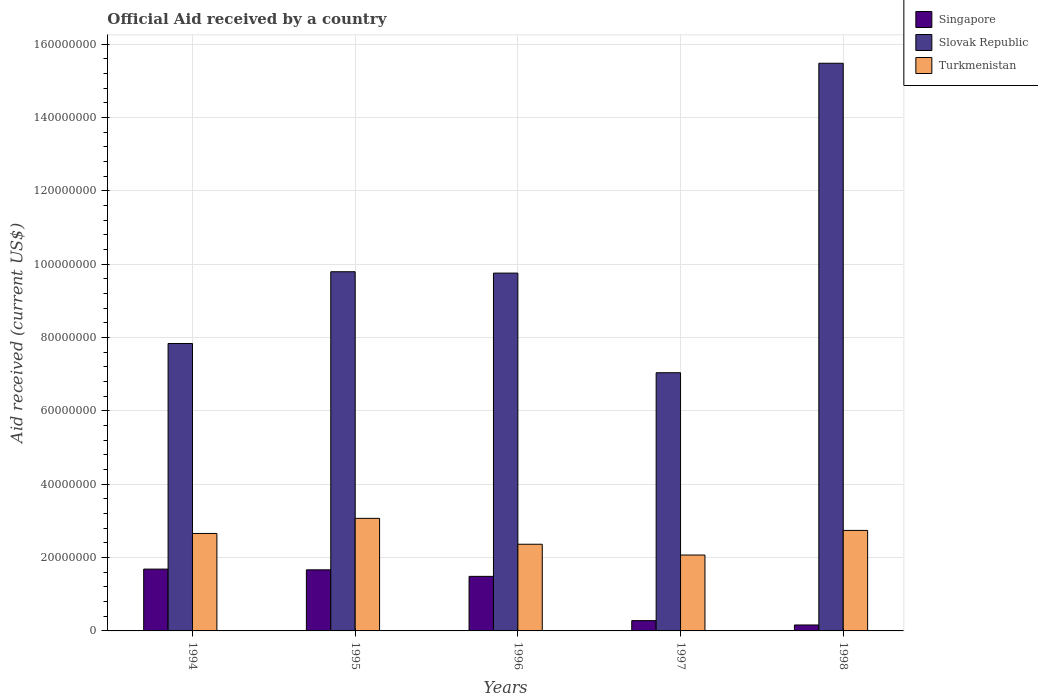Are the number of bars per tick equal to the number of legend labels?
Offer a very short reply. Yes. Are the number of bars on each tick of the X-axis equal?
Your answer should be very brief. Yes. In how many cases, is the number of bars for a given year not equal to the number of legend labels?
Provide a short and direct response. 0. What is the net official aid received in Singapore in 1996?
Your answer should be compact. 1.49e+07. Across all years, what is the maximum net official aid received in Slovak Republic?
Give a very brief answer. 1.55e+08. Across all years, what is the minimum net official aid received in Turkmenistan?
Your answer should be very brief. 2.07e+07. In which year was the net official aid received in Turkmenistan maximum?
Your answer should be compact. 1995. In which year was the net official aid received in Slovak Republic minimum?
Make the answer very short. 1997. What is the total net official aid received in Slovak Republic in the graph?
Give a very brief answer. 4.99e+08. What is the difference between the net official aid received in Turkmenistan in 1995 and that in 1998?
Provide a short and direct response. 3.29e+06. What is the difference between the net official aid received in Turkmenistan in 1997 and the net official aid received in Slovak Republic in 1994?
Your response must be concise. -5.77e+07. What is the average net official aid received in Turkmenistan per year?
Your answer should be very brief. 2.58e+07. In the year 1997, what is the difference between the net official aid received in Turkmenistan and net official aid received in Slovak Republic?
Ensure brevity in your answer.  -4.97e+07. What is the ratio of the net official aid received in Turkmenistan in 1994 to that in 1996?
Your answer should be very brief. 1.12. In how many years, is the net official aid received in Turkmenistan greater than the average net official aid received in Turkmenistan taken over all years?
Offer a very short reply. 3. What does the 2nd bar from the left in 1998 represents?
Offer a terse response. Slovak Republic. What does the 3rd bar from the right in 1997 represents?
Your answer should be very brief. Singapore. Are all the bars in the graph horizontal?
Offer a very short reply. No. How many years are there in the graph?
Provide a succinct answer. 5. What is the difference between two consecutive major ticks on the Y-axis?
Offer a terse response. 2.00e+07. Does the graph contain any zero values?
Provide a short and direct response. No. Does the graph contain grids?
Provide a short and direct response. Yes. What is the title of the graph?
Give a very brief answer. Official Aid received by a country. What is the label or title of the X-axis?
Offer a terse response. Years. What is the label or title of the Y-axis?
Offer a terse response. Aid received (current US$). What is the Aid received (current US$) in Singapore in 1994?
Provide a short and direct response. 1.69e+07. What is the Aid received (current US$) of Slovak Republic in 1994?
Make the answer very short. 7.84e+07. What is the Aid received (current US$) of Turkmenistan in 1994?
Provide a succinct answer. 2.66e+07. What is the Aid received (current US$) of Singapore in 1995?
Provide a succinct answer. 1.67e+07. What is the Aid received (current US$) in Slovak Republic in 1995?
Your answer should be compact. 9.80e+07. What is the Aid received (current US$) in Turkmenistan in 1995?
Your response must be concise. 3.07e+07. What is the Aid received (current US$) in Singapore in 1996?
Keep it short and to the point. 1.49e+07. What is the Aid received (current US$) of Slovak Republic in 1996?
Ensure brevity in your answer.  9.76e+07. What is the Aid received (current US$) in Turkmenistan in 1996?
Your answer should be compact. 2.36e+07. What is the Aid received (current US$) in Singapore in 1997?
Provide a succinct answer. 2.81e+06. What is the Aid received (current US$) of Slovak Republic in 1997?
Your response must be concise. 7.04e+07. What is the Aid received (current US$) in Turkmenistan in 1997?
Make the answer very short. 2.07e+07. What is the Aid received (current US$) in Singapore in 1998?
Provide a short and direct response. 1.62e+06. What is the Aid received (current US$) of Slovak Republic in 1998?
Ensure brevity in your answer.  1.55e+08. What is the Aid received (current US$) of Turkmenistan in 1998?
Your answer should be very brief. 2.74e+07. Across all years, what is the maximum Aid received (current US$) in Singapore?
Ensure brevity in your answer.  1.69e+07. Across all years, what is the maximum Aid received (current US$) of Slovak Republic?
Your answer should be very brief. 1.55e+08. Across all years, what is the maximum Aid received (current US$) of Turkmenistan?
Make the answer very short. 3.07e+07. Across all years, what is the minimum Aid received (current US$) of Singapore?
Keep it short and to the point. 1.62e+06. Across all years, what is the minimum Aid received (current US$) in Slovak Republic?
Provide a succinct answer. 7.04e+07. Across all years, what is the minimum Aid received (current US$) in Turkmenistan?
Provide a succinct answer. 2.07e+07. What is the total Aid received (current US$) of Singapore in the graph?
Provide a succinct answer. 5.28e+07. What is the total Aid received (current US$) in Slovak Republic in the graph?
Offer a very short reply. 4.99e+08. What is the total Aid received (current US$) of Turkmenistan in the graph?
Ensure brevity in your answer.  1.29e+08. What is the difference between the Aid received (current US$) of Slovak Republic in 1994 and that in 1995?
Your answer should be very brief. -1.96e+07. What is the difference between the Aid received (current US$) in Turkmenistan in 1994 and that in 1995?
Your answer should be very brief. -4.12e+06. What is the difference between the Aid received (current US$) in Singapore in 1994 and that in 1996?
Your answer should be compact. 1.98e+06. What is the difference between the Aid received (current US$) in Slovak Republic in 1994 and that in 1996?
Provide a short and direct response. -1.92e+07. What is the difference between the Aid received (current US$) in Turkmenistan in 1994 and that in 1996?
Give a very brief answer. 2.94e+06. What is the difference between the Aid received (current US$) of Singapore in 1994 and that in 1997?
Make the answer very short. 1.40e+07. What is the difference between the Aid received (current US$) of Slovak Republic in 1994 and that in 1997?
Your answer should be compact. 7.97e+06. What is the difference between the Aid received (current US$) of Turkmenistan in 1994 and that in 1997?
Offer a very short reply. 5.88e+06. What is the difference between the Aid received (current US$) of Singapore in 1994 and that in 1998?
Make the answer very short. 1.52e+07. What is the difference between the Aid received (current US$) of Slovak Republic in 1994 and that in 1998?
Your answer should be very brief. -7.64e+07. What is the difference between the Aid received (current US$) of Turkmenistan in 1994 and that in 1998?
Your answer should be compact. -8.30e+05. What is the difference between the Aid received (current US$) of Singapore in 1995 and that in 1996?
Keep it short and to the point. 1.78e+06. What is the difference between the Aid received (current US$) in Slovak Republic in 1995 and that in 1996?
Ensure brevity in your answer.  3.70e+05. What is the difference between the Aid received (current US$) of Turkmenistan in 1995 and that in 1996?
Ensure brevity in your answer.  7.06e+06. What is the difference between the Aid received (current US$) of Singapore in 1995 and that in 1997?
Offer a terse response. 1.38e+07. What is the difference between the Aid received (current US$) of Slovak Republic in 1995 and that in 1997?
Provide a short and direct response. 2.75e+07. What is the difference between the Aid received (current US$) of Turkmenistan in 1995 and that in 1997?
Ensure brevity in your answer.  1.00e+07. What is the difference between the Aid received (current US$) of Singapore in 1995 and that in 1998?
Give a very brief answer. 1.50e+07. What is the difference between the Aid received (current US$) of Slovak Republic in 1995 and that in 1998?
Your answer should be compact. -5.69e+07. What is the difference between the Aid received (current US$) in Turkmenistan in 1995 and that in 1998?
Make the answer very short. 3.29e+06. What is the difference between the Aid received (current US$) of Singapore in 1996 and that in 1997?
Ensure brevity in your answer.  1.21e+07. What is the difference between the Aid received (current US$) in Slovak Republic in 1996 and that in 1997?
Keep it short and to the point. 2.72e+07. What is the difference between the Aid received (current US$) of Turkmenistan in 1996 and that in 1997?
Keep it short and to the point. 2.94e+06. What is the difference between the Aid received (current US$) in Singapore in 1996 and that in 1998?
Your answer should be compact. 1.33e+07. What is the difference between the Aid received (current US$) in Slovak Republic in 1996 and that in 1998?
Ensure brevity in your answer.  -5.72e+07. What is the difference between the Aid received (current US$) of Turkmenistan in 1996 and that in 1998?
Ensure brevity in your answer.  -3.77e+06. What is the difference between the Aid received (current US$) in Singapore in 1997 and that in 1998?
Provide a succinct answer. 1.19e+06. What is the difference between the Aid received (current US$) of Slovak Republic in 1997 and that in 1998?
Ensure brevity in your answer.  -8.44e+07. What is the difference between the Aid received (current US$) of Turkmenistan in 1997 and that in 1998?
Give a very brief answer. -6.71e+06. What is the difference between the Aid received (current US$) in Singapore in 1994 and the Aid received (current US$) in Slovak Republic in 1995?
Offer a terse response. -8.11e+07. What is the difference between the Aid received (current US$) of Singapore in 1994 and the Aid received (current US$) of Turkmenistan in 1995?
Provide a short and direct response. -1.38e+07. What is the difference between the Aid received (current US$) of Slovak Republic in 1994 and the Aid received (current US$) of Turkmenistan in 1995?
Offer a terse response. 4.77e+07. What is the difference between the Aid received (current US$) of Singapore in 1994 and the Aid received (current US$) of Slovak Republic in 1996?
Give a very brief answer. -8.07e+07. What is the difference between the Aid received (current US$) in Singapore in 1994 and the Aid received (current US$) in Turkmenistan in 1996?
Your answer should be compact. -6.78e+06. What is the difference between the Aid received (current US$) in Slovak Republic in 1994 and the Aid received (current US$) in Turkmenistan in 1996?
Ensure brevity in your answer.  5.48e+07. What is the difference between the Aid received (current US$) of Singapore in 1994 and the Aid received (current US$) of Slovak Republic in 1997?
Provide a succinct answer. -5.36e+07. What is the difference between the Aid received (current US$) in Singapore in 1994 and the Aid received (current US$) in Turkmenistan in 1997?
Make the answer very short. -3.84e+06. What is the difference between the Aid received (current US$) in Slovak Republic in 1994 and the Aid received (current US$) in Turkmenistan in 1997?
Make the answer very short. 5.77e+07. What is the difference between the Aid received (current US$) of Singapore in 1994 and the Aid received (current US$) of Slovak Republic in 1998?
Your answer should be very brief. -1.38e+08. What is the difference between the Aid received (current US$) in Singapore in 1994 and the Aid received (current US$) in Turkmenistan in 1998?
Offer a terse response. -1.06e+07. What is the difference between the Aid received (current US$) in Slovak Republic in 1994 and the Aid received (current US$) in Turkmenistan in 1998?
Make the answer very short. 5.10e+07. What is the difference between the Aid received (current US$) in Singapore in 1995 and the Aid received (current US$) in Slovak Republic in 1996?
Ensure brevity in your answer.  -8.09e+07. What is the difference between the Aid received (current US$) of Singapore in 1995 and the Aid received (current US$) of Turkmenistan in 1996?
Offer a terse response. -6.98e+06. What is the difference between the Aid received (current US$) of Slovak Republic in 1995 and the Aid received (current US$) of Turkmenistan in 1996?
Ensure brevity in your answer.  7.43e+07. What is the difference between the Aid received (current US$) of Singapore in 1995 and the Aid received (current US$) of Slovak Republic in 1997?
Provide a short and direct response. -5.38e+07. What is the difference between the Aid received (current US$) of Singapore in 1995 and the Aid received (current US$) of Turkmenistan in 1997?
Provide a succinct answer. -4.04e+06. What is the difference between the Aid received (current US$) in Slovak Republic in 1995 and the Aid received (current US$) in Turkmenistan in 1997?
Ensure brevity in your answer.  7.73e+07. What is the difference between the Aid received (current US$) of Singapore in 1995 and the Aid received (current US$) of Slovak Republic in 1998?
Your response must be concise. -1.38e+08. What is the difference between the Aid received (current US$) of Singapore in 1995 and the Aid received (current US$) of Turkmenistan in 1998?
Give a very brief answer. -1.08e+07. What is the difference between the Aid received (current US$) in Slovak Republic in 1995 and the Aid received (current US$) in Turkmenistan in 1998?
Make the answer very short. 7.06e+07. What is the difference between the Aid received (current US$) of Singapore in 1996 and the Aid received (current US$) of Slovak Republic in 1997?
Your answer should be very brief. -5.55e+07. What is the difference between the Aid received (current US$) in Singapore in 1996 and the Aid received (current US$) in Turkmenistan in 1997?
Offer a terse response. -5.82e+06. What is the difference between the Aid received (current US$) in Slovak Republic in 1996 and the Aid received (current US$) in Turkmenistan in 1997?
Your response must be concise. 7.69e+07. What is the difference between the Aid received (current US$) in Singapore in 1996 and the Aid received (current US$) in Slovak Republic in 1998?
Make the answer very short. -1.40e+08. What is the difference between the Aid received (current US$) in Singapore in 1996 and the Aid received (current US$) in Turkmenistan in 1998?
Provide a short and direct response. -1.25e+07. What is the difference between the Aid received (current US$) of Slovak Republic in 1996 and the Aid received (current US$) of Turkmenistan in 1998?
Provide a succinct answer. 7.02e+07. What is the difference between the Aid received (current US$) in Singapore in 1997 and the Aid received (current US$) in Slovak Republic in 1998?
Provide a succinct answer. -1.52e+08. What is the difference between the Aid received (current US$) of Singapore in 1997 and the Aid received (current US$) of Turkmenistan in 1998?
Provide a short and direct response. -2.46e+07. What is the difference between the Aid received (current US$) in Slovak Republic in 1997 and the Aid received (current US$) in Turkmenistan in 1998?
Make the answer very short. 4.30e+07. What is the average Aid received (current US$) of Singapore per year?
Your answer should be very brief. 1.06e+07. What is the average Aid received (current US$) of Slovak Republic per year?
Your answer should be very brief. 9.98e+07. What is the average Aid received (current US$) of Turkmenistan per year?
Your response must be concise. 2.58e+07. In the year 1994, what is the difference between the Aid received (current US$) of Singapore and Aid received (current US$) of Slovak Republic?
Offer a terse response. -6.15e+07. In the year 1994, what is the difference between the Aid received (current US$) in Singapore and Aid received (current US$) in Turkmenistan?
Your answer should be very brief. -9.72e+06. In the year 1994, what is the difference between the Aid received (current US$) in Slovak Republic and Aid received (current US$) in Turkmenistan?
Provide a succinct answer. 5.18e+07. In the year 1995, what is the difference between the Aid received (current US$) of Singapore and Aid received (current US$) of Slovak Republic?
Make the answer very short. -8.13e+07. In the year 1995, what is the difference between the Aid received (current US$) of Singapore and Aid received (current US$) of Turkmenistan?
Ensure brevity in your answer.  -1.40e+07. In the year 1995, what is the difference between the Aid received (current US$) of Slovak Republic and Aid received (current US$) of Turkmenistan?
Your answer should be compact. 6.73e+07. In the year 1996, what is the difference between the Aid received (current US$) in Singapore and Aid received (current US$) in Slovak Republic?
Provide a short and direct response. -8.27e+07. In the year 1996, what is the difference between the Aid received (current US$) in Singapore and Aid received (current US$) in Turkmenistan?
Offer a very short reply. -8.76e+06. In the year 1996, what is the difference between the Aid received (current US$) in Slovak Republic and Aid received (current US$) in Turkmenistan?
Offer a terse response. 7.40e+07. In the year 1997, what is the difference between the Aid received (current US$) in Singapore and Aid received (current US$) in Slovak Republic?
Give a very brief answer. -6.76e+07. In the year 1997, what is the difference between the Aid received (current US$) of Singapore and Aid received (current US$) of Turkmenistan?
Your answer should be compact. -1.79e+07. In the year 1997, what is the difference between the Aid received (current US$) of Slovak Republic and Aid received (current US$) of Turkmenistan?
Give a very brief answer. 4.97e+07. In the year 1998, what is the difference between the Aid received (current US$) in Singapore and Aid received (current US$) in Slovak Republic?
Your answer should be very brief. -1.53e+08. In the year 1998, what is the difference between the Aid received (current US$) in Singapore and Aid received (current US$) in Turkmenistan?
Your response must be concise. -2.58e+07. In the year 1998, what is the difference between the Aid received (current US$) in Slovak Republic and Aid received (current US$) in Turkmenistan?
Provide a short and direct response. 1.27e+08. What is the ratio of the Aid received (current US$) of Slovak Republic in 1994 to that in 1995?
Your answer should be compact. 0.8. What is the ratio of the Aid received (current US$) in Turkmenistan in 1994 to that in 1995?
Provide a succinct answer. 0.87. What is the ratio of the Aid received (current US$) of Singapore in 1994 to that in 1996?
Give a very brief answer. 1.13. What is the ratio of the Aid received (current US$) in Slovak Republic in 1994 to that in 1996?
Ensure brevity in your answer.  0.8. What is the ratio of the Aid received (current US$) in Turkmenistan in 1994 to that in 1996?
Your answer should be compact. 1.12. What is the ratio of the Aid received (current US$) in Slovak Republic in 1994 to that in 1997?
Provide a succinct answer. 1.11. What is the ratio of the Aid received (current US$) in Turkmenistan in 1994 to that in 1997?
Ensure brevity in your answer.  1.28. What is the ratio of the Aid received (current US$) of Singapore in 1994 to that in 1998?
Offer a very short reply. 10.41. What is the ratio of the Aid received (current US$) in Slovak Republic in 1994 to that in 1998?
Make the answer very short. 0.51. What is the ratio of the Aid received (current US$) of Turkmenistan in 1994 to that in 1998?
Provide a short and direct response. 0.97. What is the ratio of the Aid received (current US$) of Singapore in 1995 to that in 1996?
Offer a very short reply. 1.12. What is the ratio of the Aid received (current US$) in Slovak Republic in 1995 to that in 1996?
Ensure brevity in your answer.  1. What is the ratio of the Aid received (current US$) in Turkmenistan in 1995 to that in 1996?
Offer a very short reply. 1.3. What is the ratio of the Aid received (current US$) of Singapore in 1995 to that in 1997?
Provide a succinct answer. 5.93. What is the ratio of the Aid received (current US$) of Slovak Republic in 1995 to that in 1997?
Make the answer very short. 1.39. What is the ratio of the Aid received (current US$) of Turkmenistan in 1995 to that in 1997?
Offer a terse response. 1.48. What is the ratio of the Aid received (current US$) in Singapore in 1995 to that in 1998?
Your answer should be compact. 10.28. What is the ratio of the Aid received (current US$) of Slovak Republic in 1995 to that in 1998?
Make the answer very short. 0.63. What is the ratio of the Aid received (current US$) in Turkmenistan in 1995 to that in 1998?
Provide a succinct answer. 1.12. What is the ratio of the Aid received (current US$) in Singapore in 1996 to that in 1997?
Offer a terse response. 5.3. What is the ratio of the Aid received (current US$) of Slovak Republic in 1996 to that in 1997?
Your response must be concise. 1.39. What is the ratio of the Aid received (current US$) in Turkmenistan in 1996 to that in 1997?
Make the answer very short. 1.14. What is the ratio of the Aid received (current US$) of Singapore in 1996 to that in 1998?
Provide a succinct answer. 9.19. What is the ratio of the Aid received (current US$) of Slovak Republic in 1996 to that in 1998?
Your response must be concise. 0.63. What is the ratio of the Aid received (current US$) of Turkmenistan in 1996 to that in 1998?
Give a very brief answer. 0.86. What is the ratio of the Aid received (current US$) of Singapore in 1997 to that in 1998?
Your answer should be very brief. 1.73. What is the ratio of the Aid received (current US$) of Slovak Republic in 1997 to that in 1998?
Offer a terse response. 0.45. What is the ratio of the Aid received (current US$) of Turkmenistan in 1997 to that in 1998?
Provide a succinct answer. 0.76. What is the difference between the highest and the second highest Aid received (current US$) of Singapore?
Offer a terse response. 2.00e+05. What is the difference between the highest and the second highest Aid received (current US$) in Slovak Republic?
Provide a short and direct response. 5.69e+07. What is the difference between the highest and the second highest Aid received (current US$) in Turkmenistan?
Provide a short and direct response. 3.29e+06. What is the difference between the highest and the lowest Aid received (current US$) of Singapore?
Provide a succinct answer. 1.52e+07. What is the difference between the highest and the lowest Aid received (current US$) in Slovak Republic?
Keep it short and to the point. 8.44e+07. What is the difference between the highest and the lowest Aid received (current US$) in Turkmenistan?
Your response must be concise. 1.00e+07. 